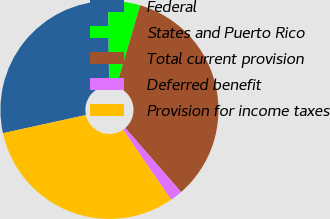Convert chart. <chart><loc_0><loc_0><loc_500><loc_500><pie_chart><fcel>Federal<fcel>States and Puerto Rico<fcel>Total current provision<fcel>Deferred benefit<fcel>Provision for income taxes<nl><fcel>28.24%<fcel>4.74%<fcel>34.04%<fcel>1.84%<fcel>31.14%<nl></chart> 